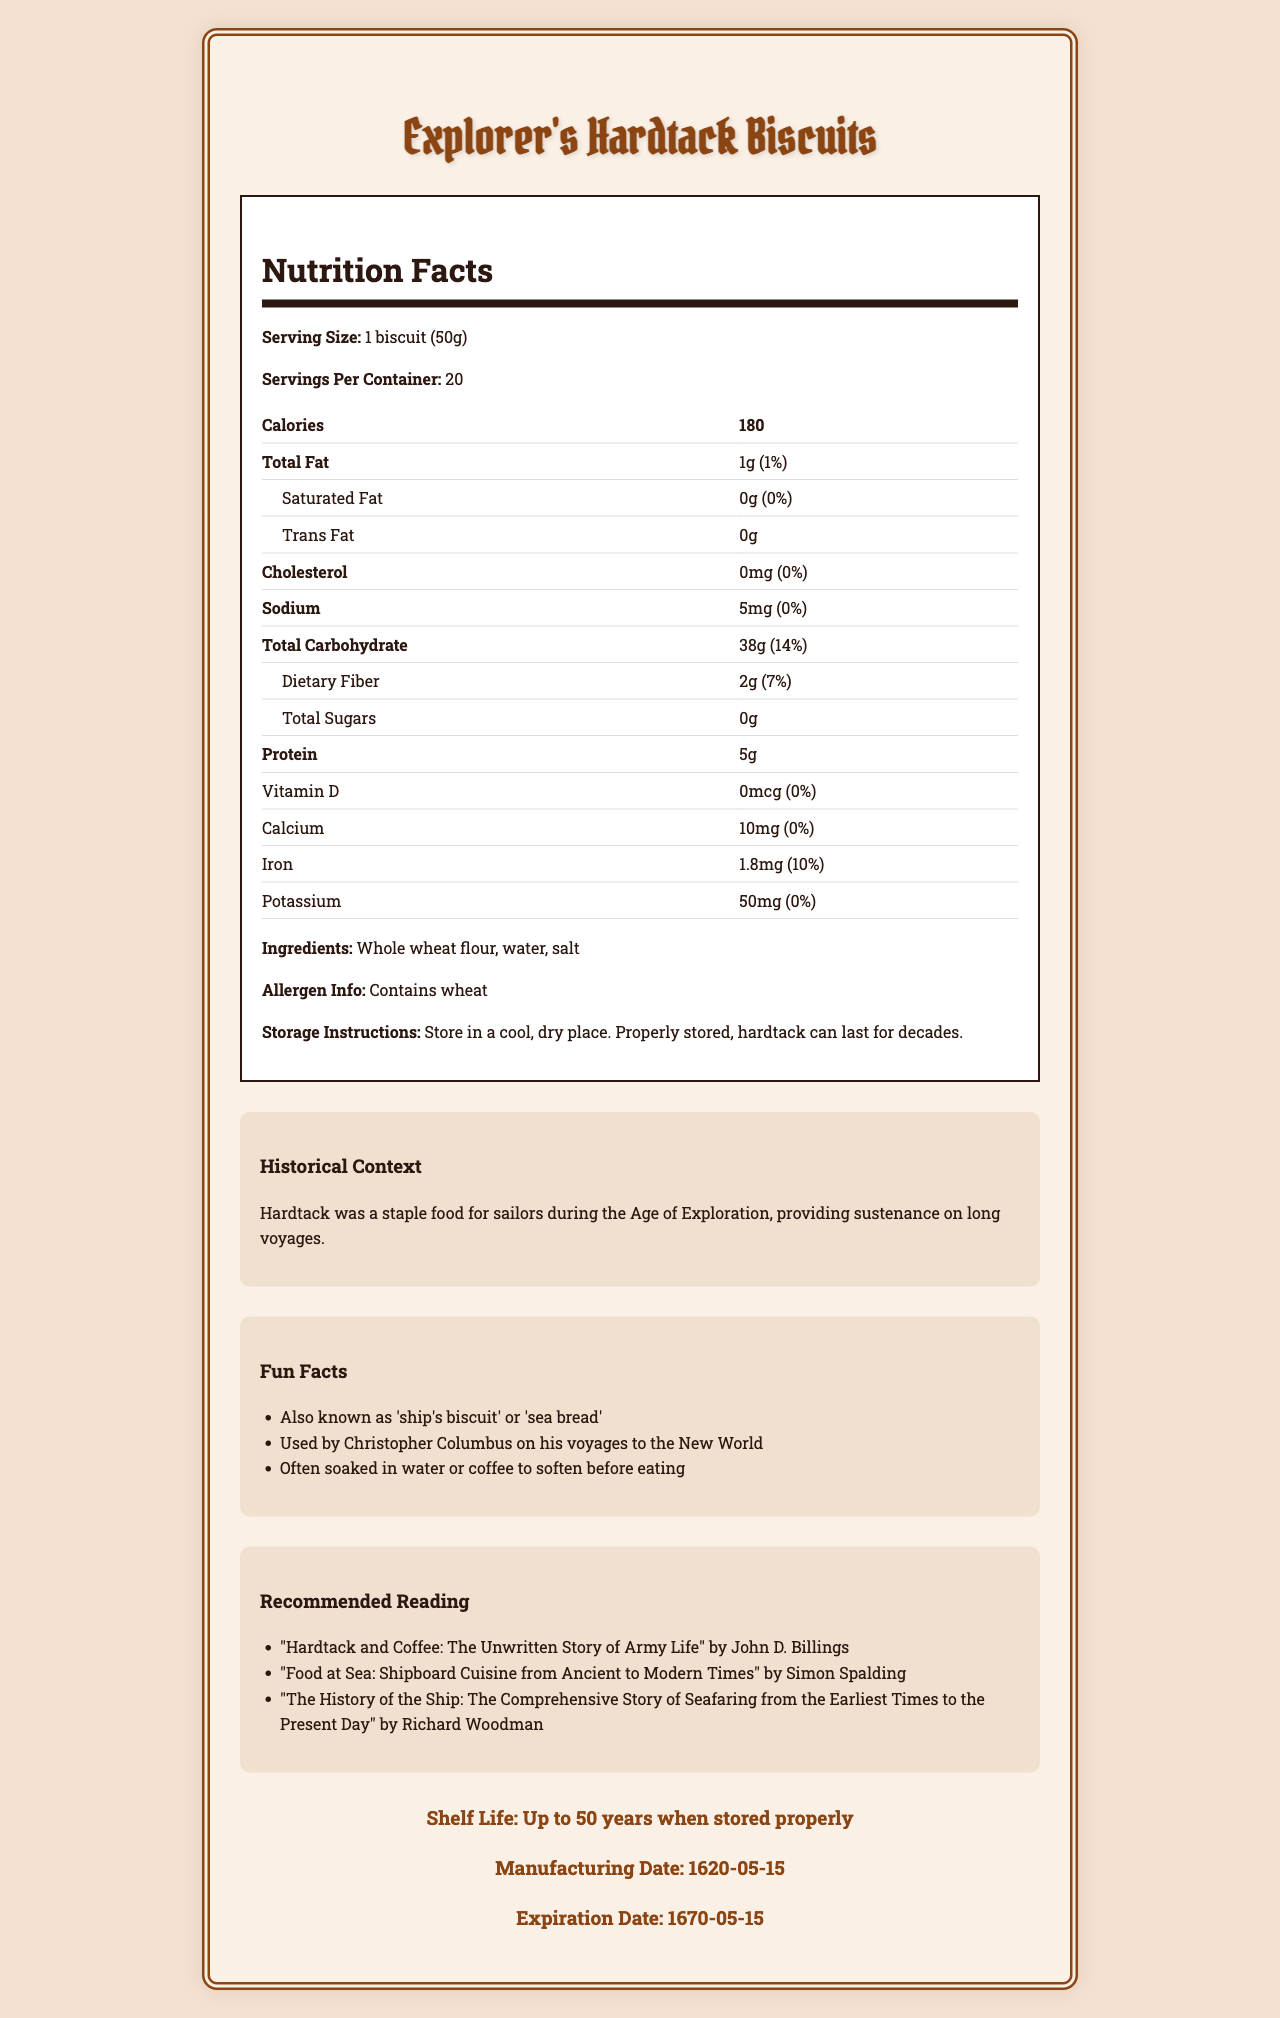what is the product name? The product name is clearly mentioned at the top of the document.
Answer: Explorer's Hardtack Biscuits how many servings are in the container? The section labeled "Nutrition Facts" specifies "Servings Per Container: 20".
Answer: 20 how many calories are in one biscuit? The calorie content is listed under "Nutrition Facts" beside "Calories".
Answer: 180 what are the primary ingredients of the hardtack biscuits? This information is listed under the ingredients section of the nutrition label.
Answer: Whole wheat flour, water, salt what is the shelf life of the hardtack biscuits? The shelf life is mentioned in the section titled "Storage Instructions" and reiterated in the "Shelf Life" section at the bottom.
Answer: Up to 50 years when stored properly which of the following nutrients has the highest daily value percentage? A. Iron B. Sodium C. Calcium D. Dietary Fiber Iron has a daily value of 10%, which is higher than Sodium (0%), Calcium (0%), and Dietary Fiber (7%).
Answer: A. Iron what is the historical significance of hardtack biscuits? This information is detailed in the "Historical Context" section.
Answer: Hardtack was a staple food for sailors during the Age of Exploration, providing sustenance on long voyages true or false: hardtack biscuits were also known as 'sea bread'. This is mentioned in the "Fun Facts" section.
Answer: True which of the following books is recommended for further reading on the history of hardtack? A. "Hardtack and Coffee: The Unwritten Story of Army Life" by John D. Billings B. "The History of Bread" by Peter Smith C. "Baking through the Ages" by Laura Jones  D. "Food on Deck: Maritime Meals" by Susan Adams This book is listed under the "Recommended Reading" section.
Answer: A. "Hardtack and Coffee: The Unwritten Story of Army Life" by John D. Billings when was the manufacturing date of the hardtack biscuits? The manufacturing date is mentioned under the "Shelf Life" section.
Answer: 1620-05-15 describe the entire document This summary covers all the main sections and provides a comprehensive overview of the entire document.
Answer: The document provides detailed nutritional information about Explorer's Hardtack Biscuits, including serving size, calorie content, and various nutrients. It summarizes the historical significance and provides fun facts about hardtack. The document lists ingredients, allergen information, storage instructions, recommended readings, and shelf life, complete with manufacturing and expiration dates. how should hardtack biscuits be stored? This information is provided in the "Storage Instructions" section.
Answer: Store in a cool, dry place how much protein is in one serving of hardtack biscuits? The protein content is listed under the "Nutrition Facts" section.
Answer: 5g do these hardtack biscuits contain any sugars? The "Total Sugars" count is listed as "0g" under "Nutrition Facts".
Answer: No what is the percentage of daily value for total carbohydrates? The daily value for total carbohydrates is noted in the "Nutrition Facts" section as 14%.
Answer: 14% which element is not mentioned in the nutrition facts? A. Vitamin C B. Iron C. Calcium D. Protein Vitamin C is not listed anywhere in the nutrition information provided.
Answer: A. Vitamin C what does not provide a daily value? This information is not given a daily value percentage in the nutrition label.
Answer: Trans Fat what is the expiration date of the hardtack biscuits? The expiration date is listed in the "Shelf Life" section.
Answer: 1670-05-15 how often were hardtack biscuits used by Christopher Columbus? The frequency of use by Christopher Columbus is not specified in the document.
Answer: Cannot be determined 